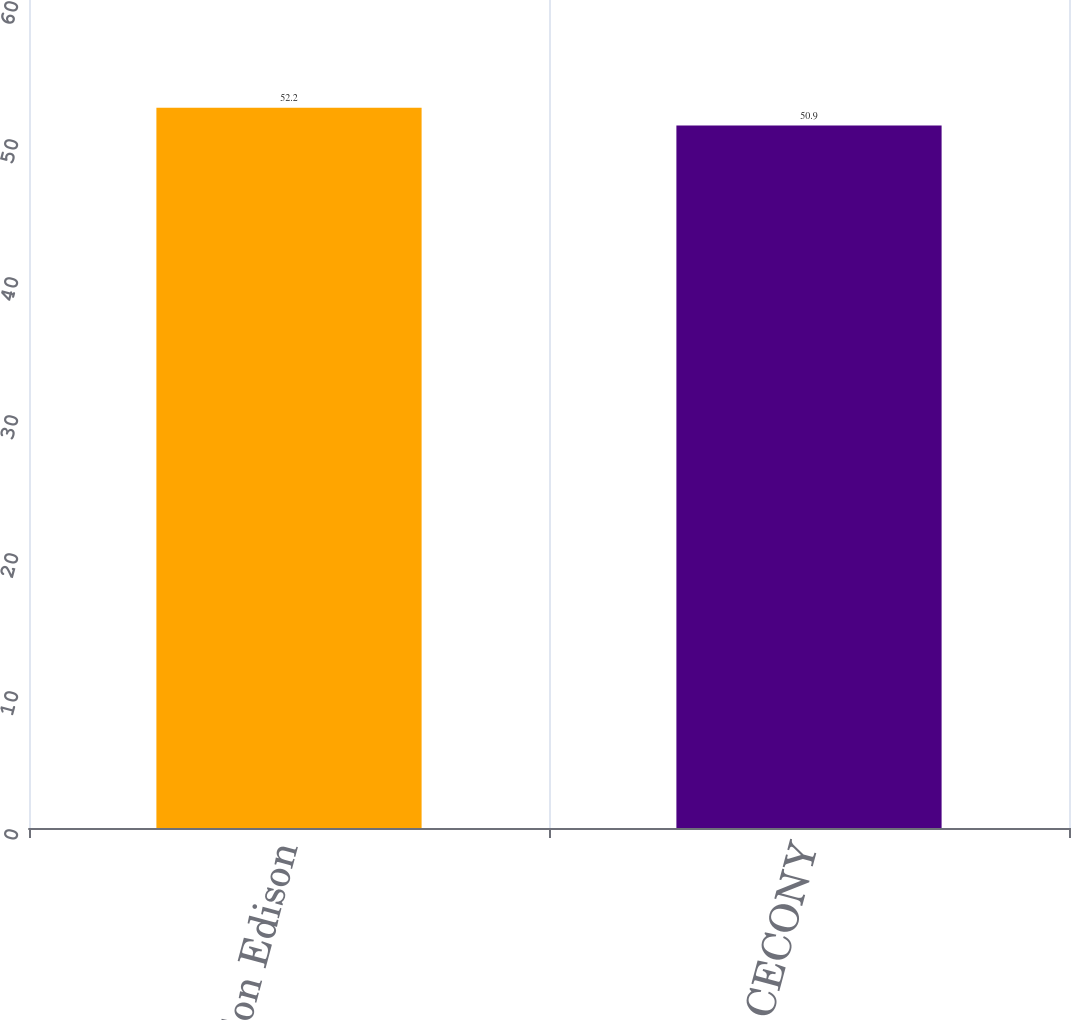<chart> <loc_0><loc_0><loc_500><loc_500><bar_chart><fcel>Con Edison<fcel>CECONY<nl><fcel>52.2<fcel>50.9<nl></chart> 